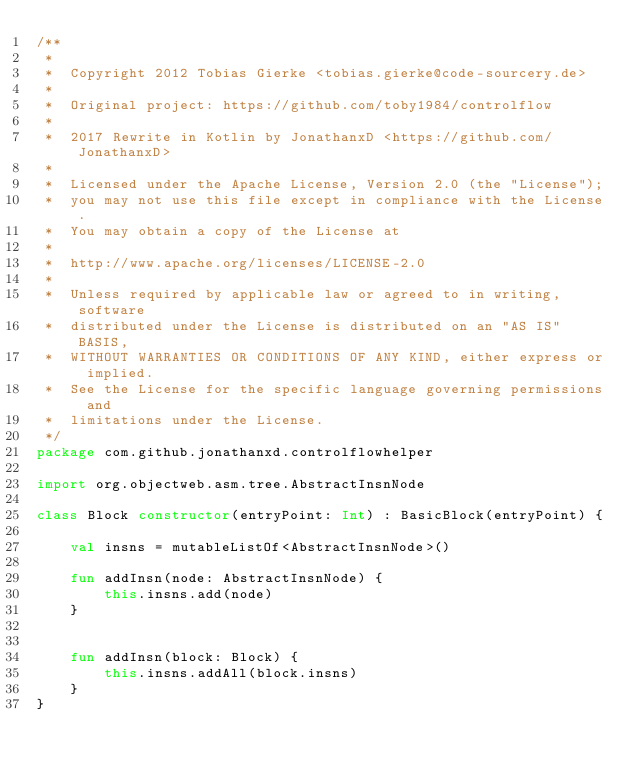<code> <loc_0><loc_0><loc_500><loc_500><_Kotlin_>/**
 *
 *  Copyright 2012 Tobias Gierke <tobias.gierke@code-sourcery.de>
 *
 *  Original project: https://github.com/toby1984/controlflow
 *
 *  2017 Rewrite in Kotlin by JonathanxD <https://github.com/JonathanxD>
 *
 *  Licensed under the Apache License, Version 2.0 (the "License");
 *  you may not use this file except in compliance with the License.
 *  You may obtain a copy of the License at
 *
 *  http://www.apache.org/licenses/LICENSE-2.0
 *
 *  Unless required by applicable law or agreed to in writing, software
 *  distributed under the License is distributed on an "AS IS" BASIS,
 *  WITHOUT WARRANTIES OR CONDITIONS OF ANY KIND, either express or implied.
 *  See the License for the specific language governing permissions and
 *  limitations under the License.
 */
package com.github.jonathanxd.controlflowhelper

import org.objectweb.asm.tree.AbstractInsnNode

class Block constructor(entryPoint: Int) : BasicBlock(entryPoint) {

    val insns = mutableListOf<AbstractInsnNode>()

    fun addInsn(node: AbstractInsnNode) {
        this.insns.add(node)
    }


    fun addInsn(block: Block) {
        this.insns.addAll(block.insns)
    }
}</code> 